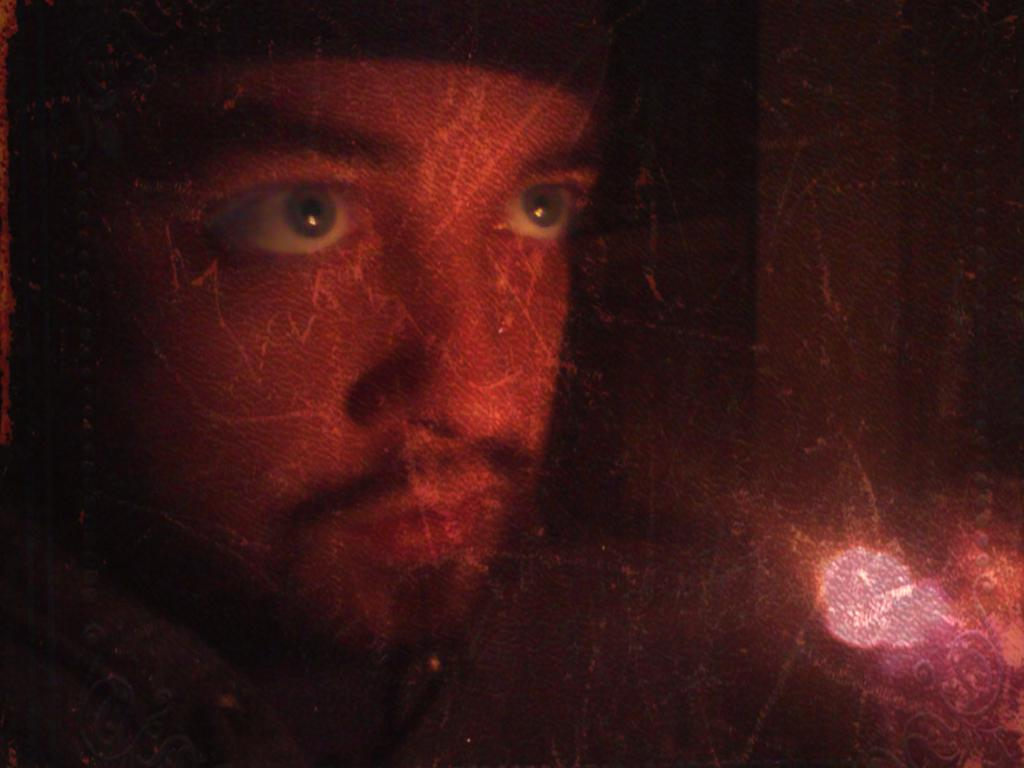What is the main subject of the image? There is a person in the image. What type of stamp can be seen on the person's forehead in the image? There is no stamp visible on the person's forehead in the image. What kind of drug is the person holding in the image? There is no drug present in the image; it only features a person. 